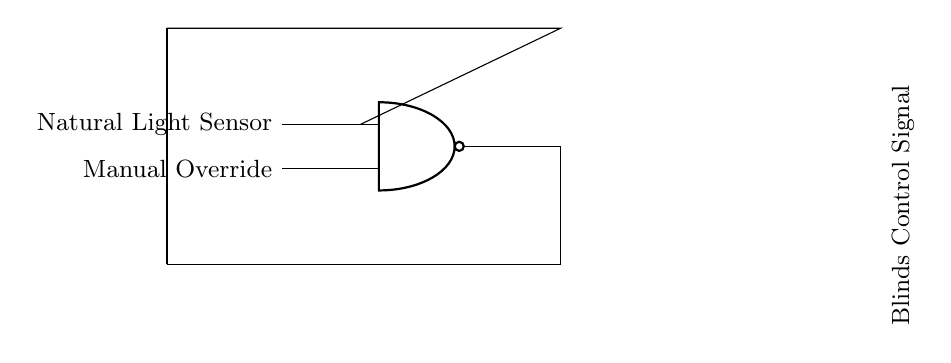What type of logic gate is used in this circuit? The circuit uses a NAND gate, which is represented by the symbol in the diagram indicating its logic function.
Answer: NAND gate What is the input for the manual override sensor? The input for the manual override is connected to one of the inputs of the NAND gate, shown on the left side of the diagram.
Answer: Manual Override How many inputs does the NAND gate have? The NAND gate is a two-input gate as indicated by the two lines connecting to it from the left side.
Answer: Two inputs What does the output signal control in this circuit? The output from the NAND gate controls the blinds, as noted by the label for the Blinds Control Signal.
Answer: Blinds Control Signal If the natural light sensor detects sufficient light, will the blinds open? No, if the natural light sensor inputs a high signal and the manual override is low, the output will be low, keeping the blinds closed.
Answer: No Explain how the NAND gate functions in this circuit. The NAND gate outputs a low signal only when both inputs are high; therefore, it allows manual control to override the sensor input, ensuring the blinds can still be adjusted for optimal lighting.
Answer: It allows manual control and blocks light input when both signals are high 